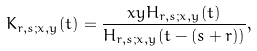<formula> <loc_0><loc_0><loc_500><loc_500>K _ { r , s ; x , y } ( t ) = \frac { x y H _ { r , s ; x , y } ( t ) } { H _ { r , s ; x , y } ( t - ( s + r ) ) } ,</formula> 